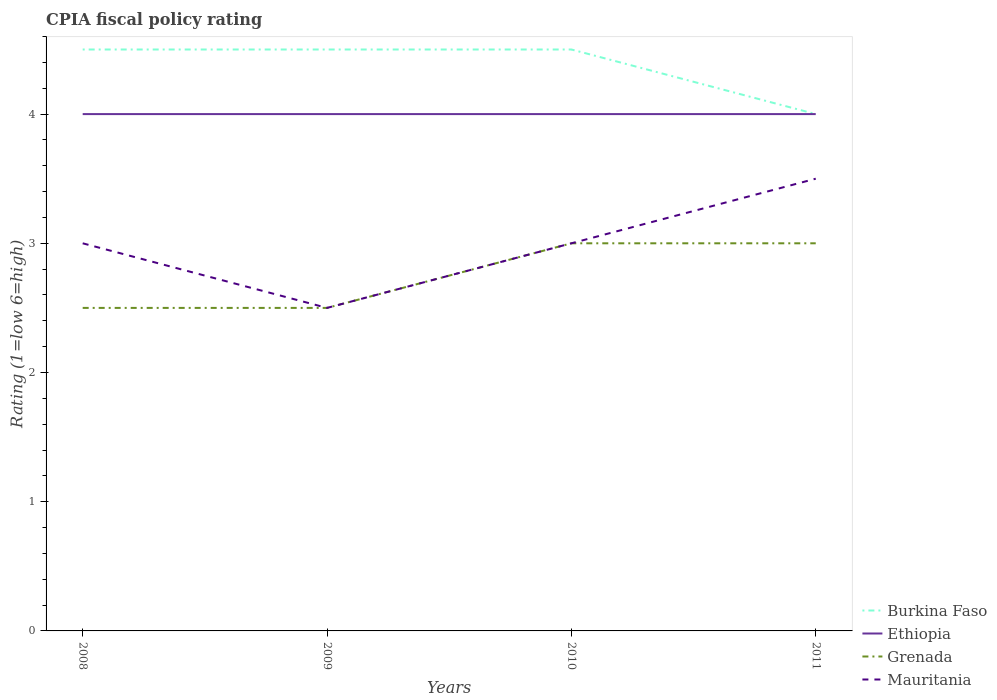How many different coloured lines are there?
Make the answer very short. 4. Does the line corresponding to Mauritania intersect with the line corresponding to Grenada?
Your answer should be very brief. Yes. What is the total CPIA rating in Ethiopia in the graph?
Offer a terse response. 0. What is the difference between the highest and the second highest CPIA rating in Burkina Faso?
Your response must be concise. 0.5. What is the difference between the highest and the lowest CPIA rating in Mauritania?
Offer a terse response. 1. How many lines are there?
Your answer should be very brief. 4. Are the values on the major ticks of Y-axis written in scientific E-notation?
Offer a terse response. No. Does the graph contain grids?
Offer a very short reply. No. Where does the legend appear in the graph?
Offer a terse response. Bottom right. How many legend labels are there?
Make the answer very short. 4. How are the legend labels stacked?
Provide a succinct answer. Vertical. What is the title of the graph?
Ensure brevity in your answer.  CPIA fiscal policy rating. What is the label or title of the X-axis?
Give a very brief answer. Years. What is the Rating (1=low 6=high) in Burkina Faso in 2008?
Give a very brief answer. 4.5. What is the Rating (1=low 6=high) in Ethiopia in 2008?
Give a very brief answer. 4. What is the Rating (1=low 6=high) in Ethiopia in 2009?
Provide a short and direct response. 4. What is the Rating (1=low 6=high) in Grenada in 2009?
Offer a terse response. 2.5. What is the Rating (1=low 6=high) of Burkina Faso in 2010?
Offer a terse response. 4.5. What is the Rating (1=low 6=high) in Mauritania in 2010?
Your answer should be compact. 3. What is the Rating (1=low 6=high) of Burkina Faso in 2011?
Offer a very short reply. 4. What is the Rating (1=low 6=high) of Grenada in 2011?
Ensure brevity in your answer.  3. What is the Rating (1=low 6=high) of Mauritania in 2011?
Provide a short and direct response. 3.5. Across all years, what is the maximum Rating (1=low 6=high) in Burkina Faso?
Ensure brevity in your answer.  4.5. Across all years, what is the maximum Rating (1=low 6=high) of Ethiopia?
Offer a terse response. 4. Across all years, what is the maximum Rating (1=low 6=high) of Mauritania?
Make the answer very short. 3.5. Across all years, what is the minimum Rating (1=low 6=high) of Burkina Faso?
Keep it short and to the point. 4. Across all years, what is the minimum Rating (1=low 6=high) in Ethiopia?
Offer a very short reply. 4. Across all years, what is the minimum Rating (1=low 6=high) of Grenada?
Offer a very short reply. 2.5. What is the total Rating (1=low 6=high) of Burkina Faso in the graph?
Provide a short and direct response. 17.5. What is the difference between the Rating (1=low 6=high) in Grenada in 2008 and that in 2009?
Give a very brief answer. 0. What is the difference between the Rating (1=low 6=high) in Grenada in 2008 and that in 2010?
Give a very brief answer. -0.5. What is the difference between the Rating (1=low 6=high) in Burkina Faso in 2008 and that in 2011?
Offer a terse response. 0.5. What is the difference between the Rating (1=low 6=high) of Ethiopia in 2008 and that in 2011?
Keep it short and to the point. 0. What is the difference between the Rating (1=low 6=high) in Grenada in 2008 and that in 2011?
Keep it short and to the point. -0.5. What is the difference between the Rating (1=low 6=high) in Mauritania in 2009 and that in 2010?
Keep it short and to the point. -0.5. What is the difference between the Rating (1=low 6=high) in Burkina Faso in 2009 and that in 2011?
Offer a terse response. 0.5. What is the difference between the Rating (1=low 6=high) in Grenada in 2009 and that in 2011?
Offer a very short reply. -0.5. What is the difference between the Rating (1=low 6=high) of Mauritania in 2009 and that in 2011?
Offer a terse response. -1. What is the difference between the Rating (1=low 6=high) in Burkina Faso in 2010 and that in 2011?
Provide a short and direct response. 0.5. What is the difference between the Rating (1=low 6=high) in Grenada in 2010 and that in 2011?
Keep it short and to the point. 0. What is the difference between the Rating (1=low 6=high) of Burkina Faso in 2008 and the Rating (1=low 6=high) of Grenada in 2009?
Offer a terse response. 2. What is the difference between the Rating (1=low 6=high) in Ethiopia in 2008 and the Rating (1=low 6=high) in Mauritania in 2009?
Give a very brief answer. 1.5. What is the difference between the Rating (1=low 6=high) of Grenada in 2008 and the Rating (1=low 6=high) of Mauritania in 2009?
Provide a succinct answer. 0. What is the difference between the Rating (1=low 6=high) of Burkina Faso in 2008 and the Rating (1=low 6=high) of Ethiopia in 2010?
Ensure brevity in your answer.  0.5. What is the difference between the Rating (1=low 6=high) of Burkina Faso in 2008 and the Rating (1=low 6=high) of Grenada in 2010?
Provide a succinct answer. 1.5. What is the difference between the Rating (1=low 6=high) of Ethiopia in 2008 and the Rating (1=low 6=high) of Mauritania in 2010?
Provide a short and direct response. 1. What is the difference between the Rating (1=low 6=high) in Grenada in 2008 and the Rating (1=low 6=high) in Mauritania in 2010?
Your answer should be very brief. -0.5. What is the difference between the Rating (1=low 6=high) of Burkina Faso in 2008 and the Rating (1=low 6=high) of Mauritania in 2011?
Offer a very short reply. 1. What is the difference between the Rating (1=low 6=high) in Ethiopia in 2008 and the Rating (1=low 6=high) in Grenada in 2011?
Your response must be concise. 1. What is the difference between the Rating (1=low 6=high) of Ethiopia in 2008 and the Rating (1=low 6=high) of Mauritania in 2011?
Ensure brevity in your answer.  0.5. What is the difference between the Rating (1=low 6=high) in Grenada in 2008 and the Rating (1=low 6=high) in Mauritania in 2011?
Give a very brief answer. -1. What is the difference between the Rating (1=low 6=high) of Burkina Faso in 2009 and the Rating (1=low 6=high) of Mauritania in 2010?
Provide a succinct answer. 1.5. What is the difference between the Rating (1=low 6=high) of Ethiopia in 2009 and the Rating (1=low 6=high) of Mauritania in 2010?
Give a very brief answer. 1. What is the difference between the Rating (1=low 6=high) in Grenada in 2009 and the Rating (1=low 6=high) in Mauritania in 2010?
Make the answer very short. -0.5. What is the difference between the Rating (1=low 6=high) of Burkina Faso in 2009 and the Rating (1=low 6=high) of Ethiopia in 2011?
Keep it short and to the point. 0.5. What is the difference between the Rating (1=low 6=high) of Ethiopia in 2009 and the Rating (1=low 6=high) of Grenada in 2011?
Provide a short and direct response. 1. What is the difference between the Rating (1=low 6=high) of Ethiopia in 2009 and the Rating (1=low 6=high) of Mauritania in 2011?
Your response must be concise. 0.5. What is the difference between the Rating (1=low 6=high) in Grenada in 2009 and the Rating (1=low 6=high) in Mauritania in 2011?
Give a very brief answer. -1. What is the difference between the Rating (1=low 6=high) in Ethiopia in 2010 and the Rating (1=low 6=high) in Mauritania in 2011?
Your answer should be compact. 0.5. What is the average Rating (1=low 6=high) in Burkina Faso per year?
Make the answer very short. 4.38. What is the average Rating (1=low 6=high) in Ethiopia per year?
Your answer should be compact. 4. What is the average Rating (1=low 6=high) in Grenada per year?
Your response must be concise. 2.75. In the year 2008, what is the difference between the Rating (1=low 6=high) in Burkina Faso and Rating (1=low 6=high) in Ethiopia?
Keep it short and to the point. 0.5. In the year 2008, what is the difference between the Rating (1=low 6=high) in Burkina Faso and Rating (1=low 6=high) in Grenada?
Ensure brevity in your answer.  2. In the year 2008, what is the difference between the Rating (1=low 6=high) of Ethiopia and Rating (1=low 6=high) of Mauritania?
Your answer should be compact. 1. In the year 2008, what is the difference between the Rating (1=low 6=high) in Grenada and Rating (1=low 6=high) in Mauritania?
Give a very brief answer. -0.5. In the year 2009, what is the difference between the Rating (1=low 6=high) of Burkina Faso and Rating (1=low 6=high) of Grenada?
Provide a short and direct response. 2. In the year 2009, what is the difference between the Rating (1=low 6=high) in Burkina Faso and Rating (1=low 6=high) in Mauritania?
Give a very brief answer. 2. In the year 2009, what is the difference between the Rating (1=low 6=high) of Ethiopia and Rating (1=low 6=high) of Grenada?
Your answer should be compact. 1.5. In the year 2009, what is the difference between the Rating (1=low 6=high) of Ethiopia and Rating (1=low 6=high) of Mauritania?
Ensure brevity in your answer.  1.5. In the year 2009, what is the difference between the Rating (1=low 6=high) of Grenada and Rating (1=low 6=high) of Mauritania?
Offer a terse response. 0. In the year 2010, what is the difference between the Rating (1=low 6=high) of Burkina Faso and Rating (1=low 6=high) of Ethiopia?
Your answer should be very brief. 0.5. In the year 2010, what is the difference between the Rating (1=low 6=high) of Burkina Faso and Rating (1=low 6=high) of Grenada?
Offer a terse response. 1.5. In the year 2011, what is the difference between the Rating (1=low 6=high) of Burkina Faso and Rating (1=low 6=high) of Ethiopia?
Your answer should be compact. 0. In the year 2011, what is the difference between the Rating (1=low 6=high) of Burkina Faso and Rating (1=low 6=high) of Mauritania?
Offer a very short reply. 0.5. In the year 2011, what is the difference between the Rating (1=low 6=high) of Ethiopia and Rating (1=low 6=high) of Mauritania?
Give a very brief answer. 0.5. In the year 2011, what is the difference between the Rating (1=low 6=high) of Grenada and Rating (1=low 6=high) of Mauritania?
Provide a succinct answer. -0.5. What is the ratio of the Rating (1=low 6=high) of Ethiopia in 2008 to that in 2009?
Make the answer very short. 1. What is the ratio of the Rating (1=low 6=high) of Burkina Faso in 2008 to that in 2010?
Your response must be concise. 1. What is the ratio of the Rating (1=low 6=high) in Ethiopia in 2008 to that in 2010?
Offer a very short reply. 1. What is the ratio of the Rating (1=low 6=high) of Grenada in 2008 to that in 2010?
Your response must be concise. 0.83. What is the ratio of the Rating (1=low 6=high) of Mauritania in 2008 to that in 2010?
Keep it short and to the point. 1. What is the ratio of the Rating (1=low 6=high) of Burkina Faso in 2008 to that in 2011?
Ensure brevity in your answer.  1.12. What is the ratio of the Rating (1=low 6=high) in Ethiopia in 2008 to that in 2011?
Your answer should be compact. 1. What is the ratio of the Rating (1=low 6=high) in Grenada in 2008 to that in 2011?
Ensure brevity in your answer.  0.83. What is the ratio of the Rating (1=low 6=high) of Mauritania in 2008 to that in 2011?
Provide a succinct answer. 0.86. What is the ratio of the Rating (1=low 6=high) in Grenada in 2009 to that in 2011?
Keep it short and to the point. 0.83. What is the ratio of the Rating (1=low 6=high) in Mauritania in 2009 to that in 2011?
Give a very brief answer. 0.71. What is the ratio of the Rating (1=low 6=high) of Ethiopia in 2010 to that in 2011?
Keep it short and to the point. 1. What is the ratio of the Rating (1=low 6=high) of Grenada in 2010 to that in 2011?
Offer a very short reply. 1. What is the ratio of the Rating (1=low 6=high) in Mauritania in 2010 to that in 2011?
Provide a succinct answer. 0.86. What is the difference between the highest and the second highest Rating (1=low 6=high) in Ethiopia?
Make the answer very short. 0. What is the difference between the highest and the second highest Rating (1=low 6=high) in Grenada?
Offer a terse response. 0. What is the difference between the highest and the lowest Rating (1=low 6=high) of Burkina Faso?
Your answer should be very brief. 0.5. 